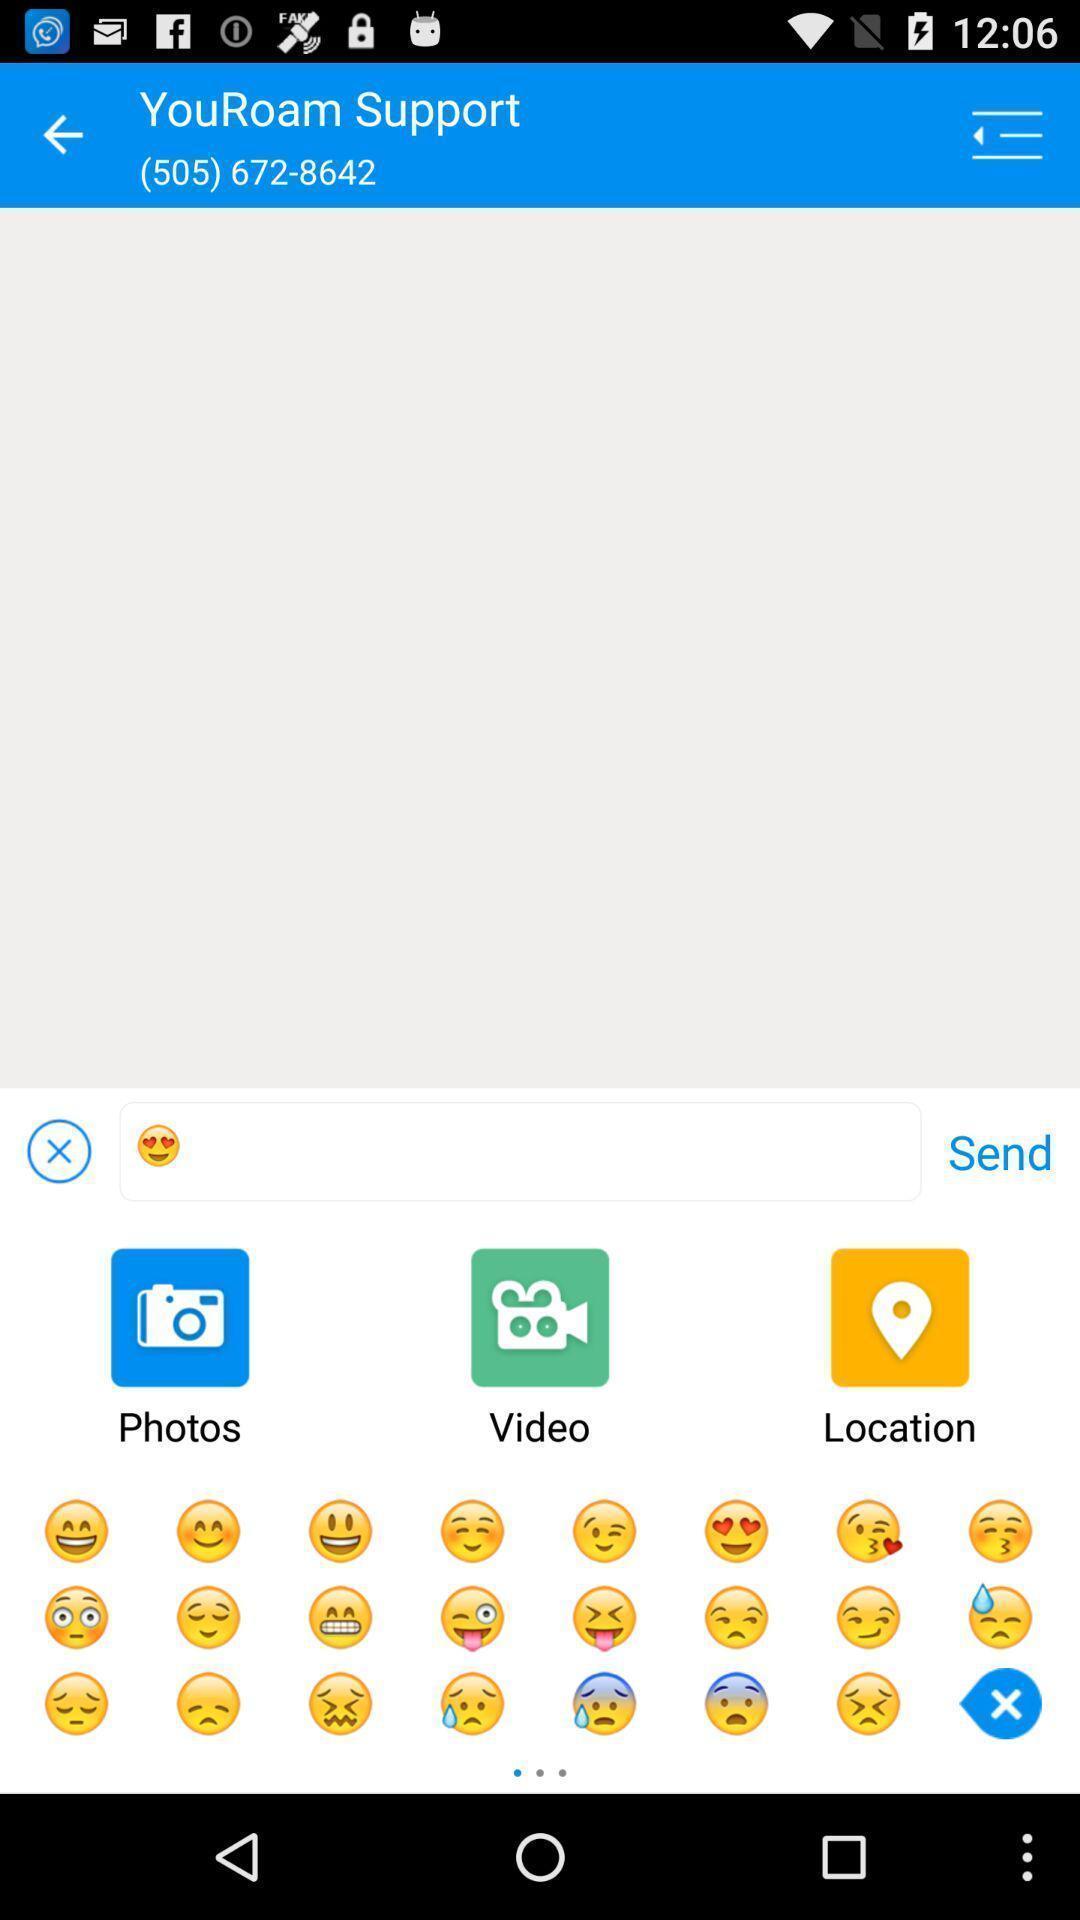Describe the visual elements of this screenshot. Support chat page displayed of a communications app. 